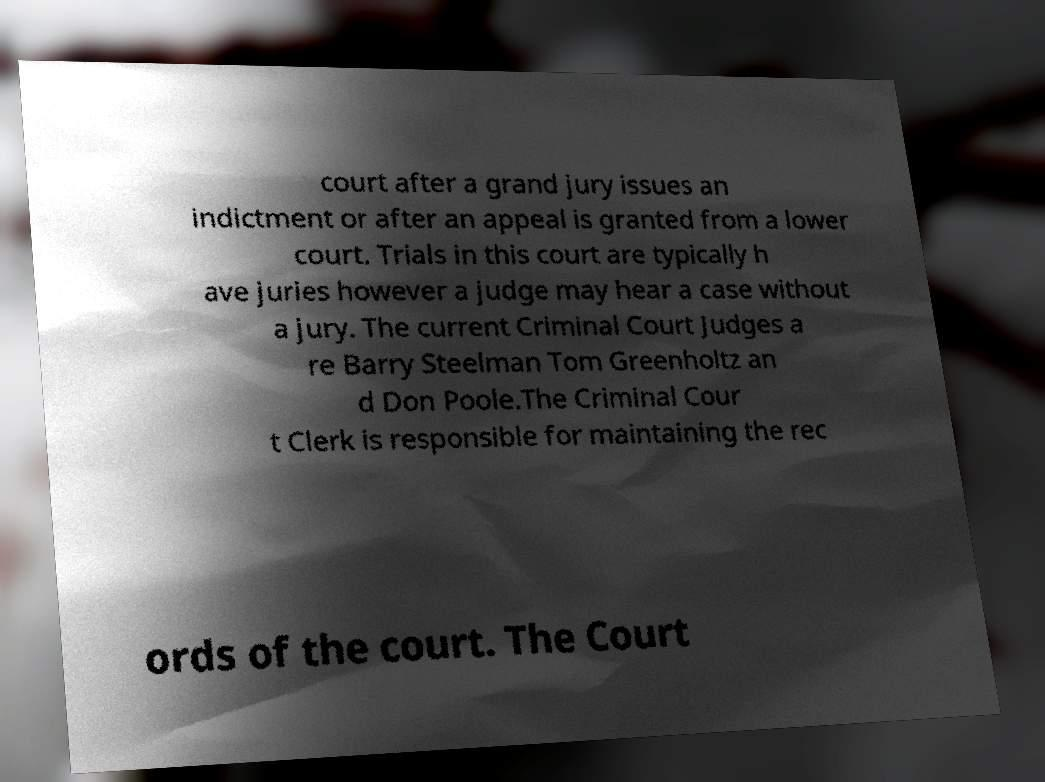For documentation purposes, I need the text within this image transcribed. Could you provide that? court after a grand jury issues an indictment or after an appeal is granted from a lower court. Trials in this court are typically h ave juries however a judge may hear a case without a jury. The current Criminal Court Judges a re Barry Steelman Tom Greenholtz an d Don Poole.The Criminal Cour t Clerk is responsible for maintaining the rec ords of the court. The Court 